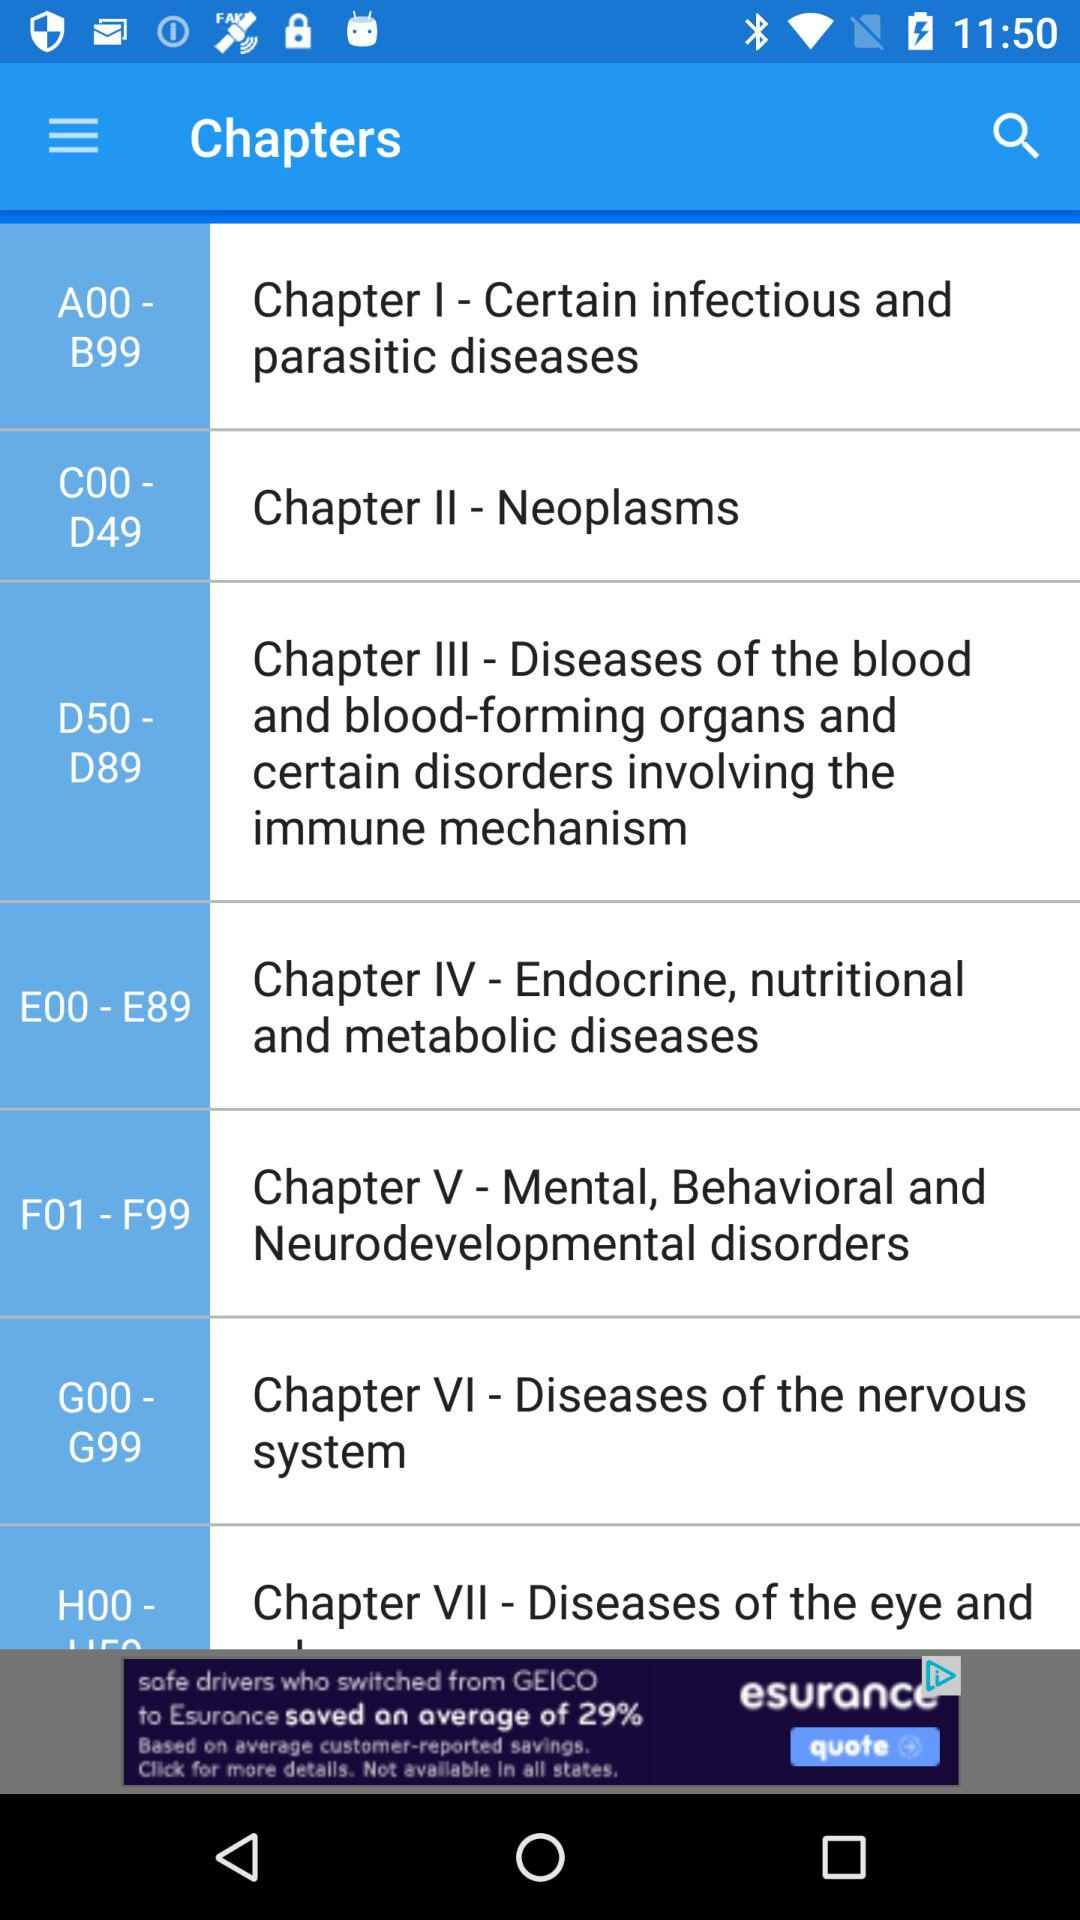What topic is covered in Chapter I? The topic is "Certain infectious and parasitic diseases". 